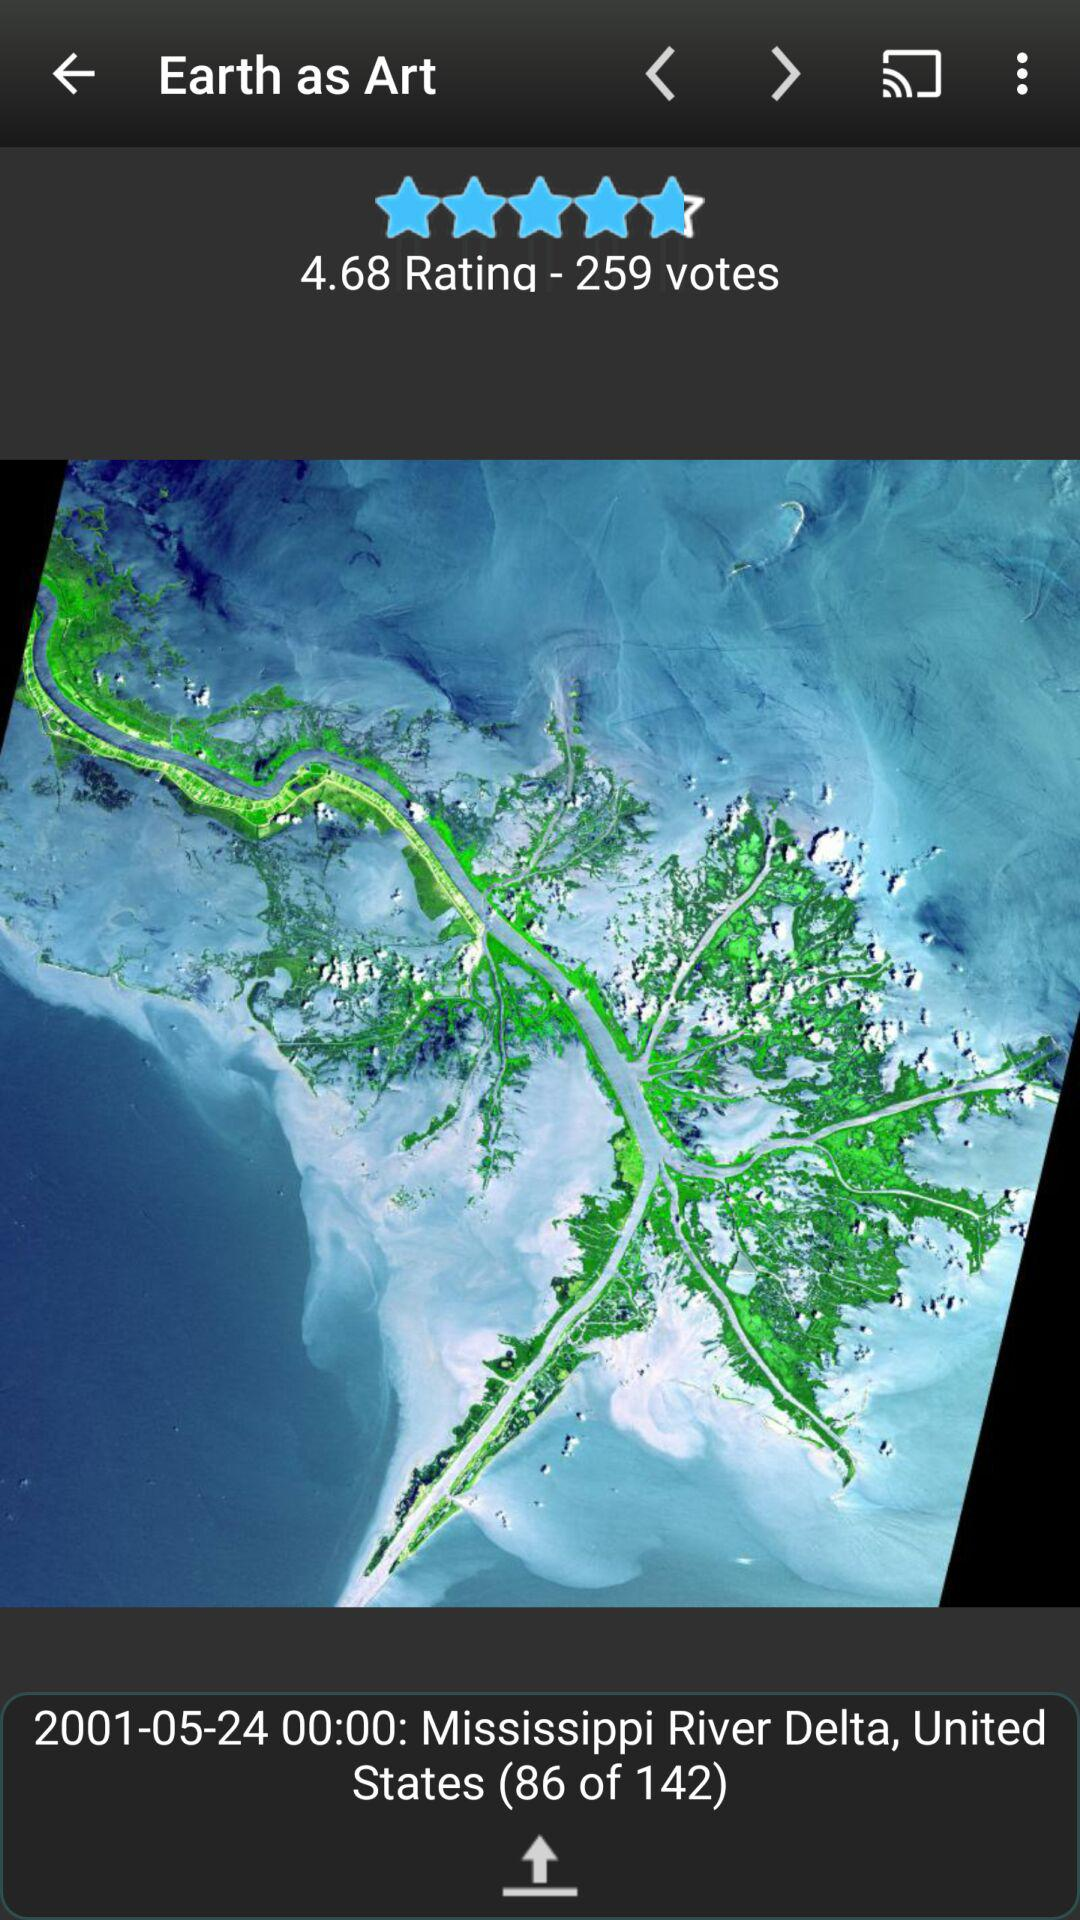How many votes are there? There are 259 votes. 